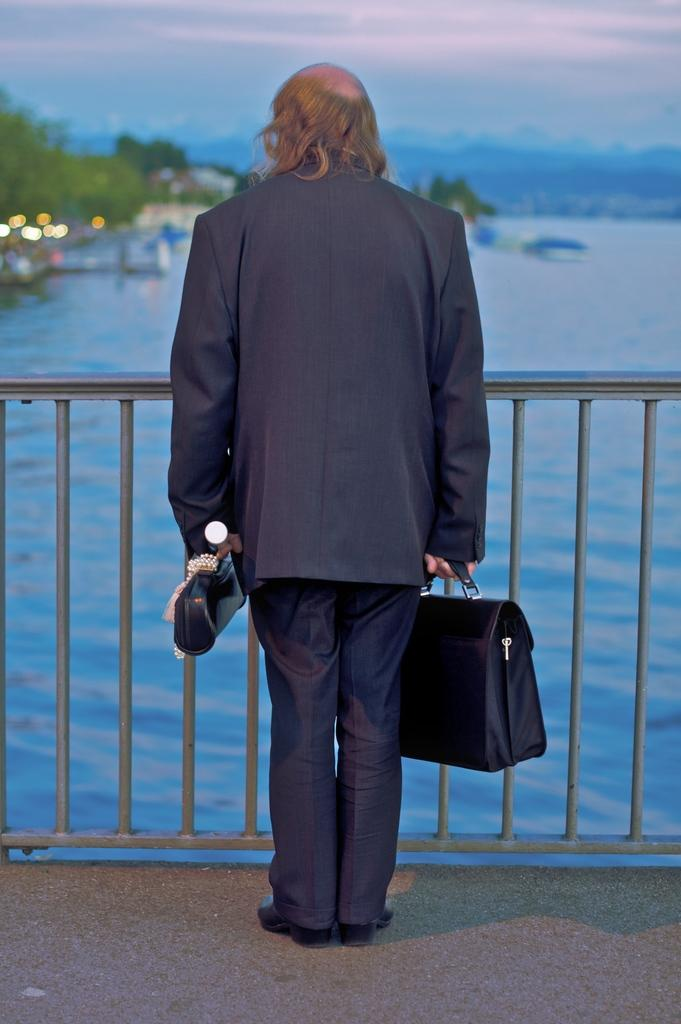What is the main subject of the picture? The main subject of the picture is a man. What is the man doing in the image? The man is standing in the image. What is the man holding in his hand? The man is holding a bag in his hand. What can be seen in the background of the image? Water, trees, and the sky are visible in the background of the image. What is the condition of the sky in the image? The sky is cloudy in the image. What type of alarm can be heard going off in the image? There is no alarm present in the image, and therefore no such sound can be heard. How does the man generate heat in the image? There is no indication in the image that the man is generating heat or that heat is a factor in the image. 